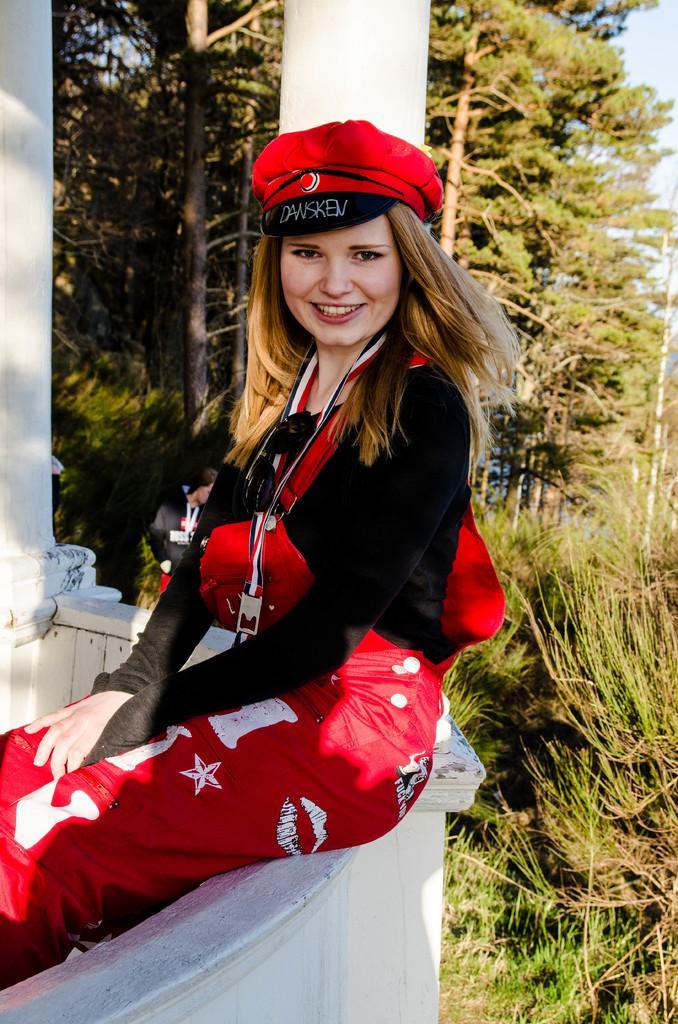Describe this image in one or two sentences. A beautiful girl is sitting on the wall, she wore a black color t-shirt and a red color trouser, cap. Behind her there are trees. 